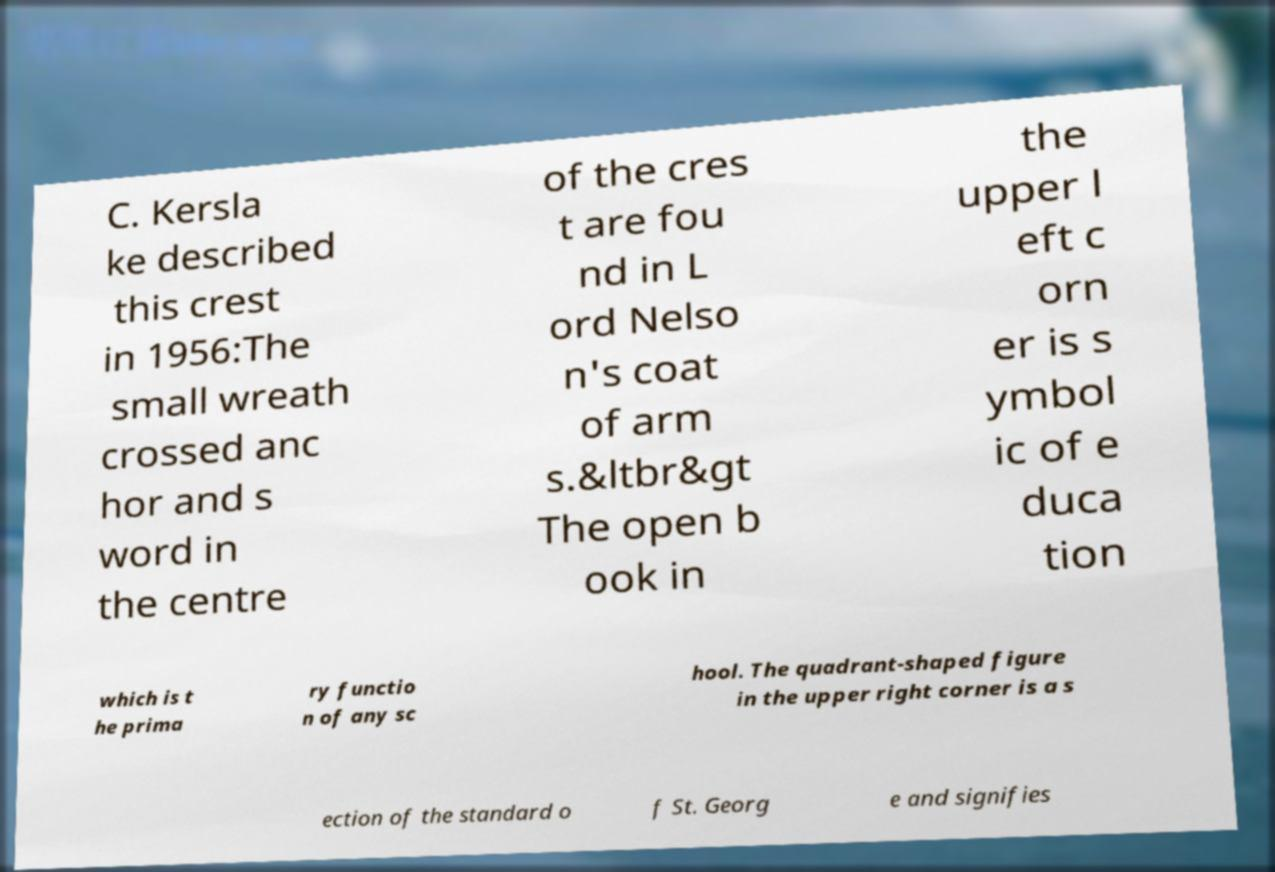Please read and relay the text visible in this image. What does it say? C. Kersla ke described this crest in 1956:The small wreath crossed anc hor and s word in the centre of the cres t are fou nd in L ord Nelso n's coat of arm s.&ltbr&gt The open b ook in the upper l eft c orn er is s ymbol ic of e duca tion which is t he prima ry functio n of any sc hool. The quadrant-shaped figure in the upper right corner is a s ection of the standard o f St. Georg e and signifies 